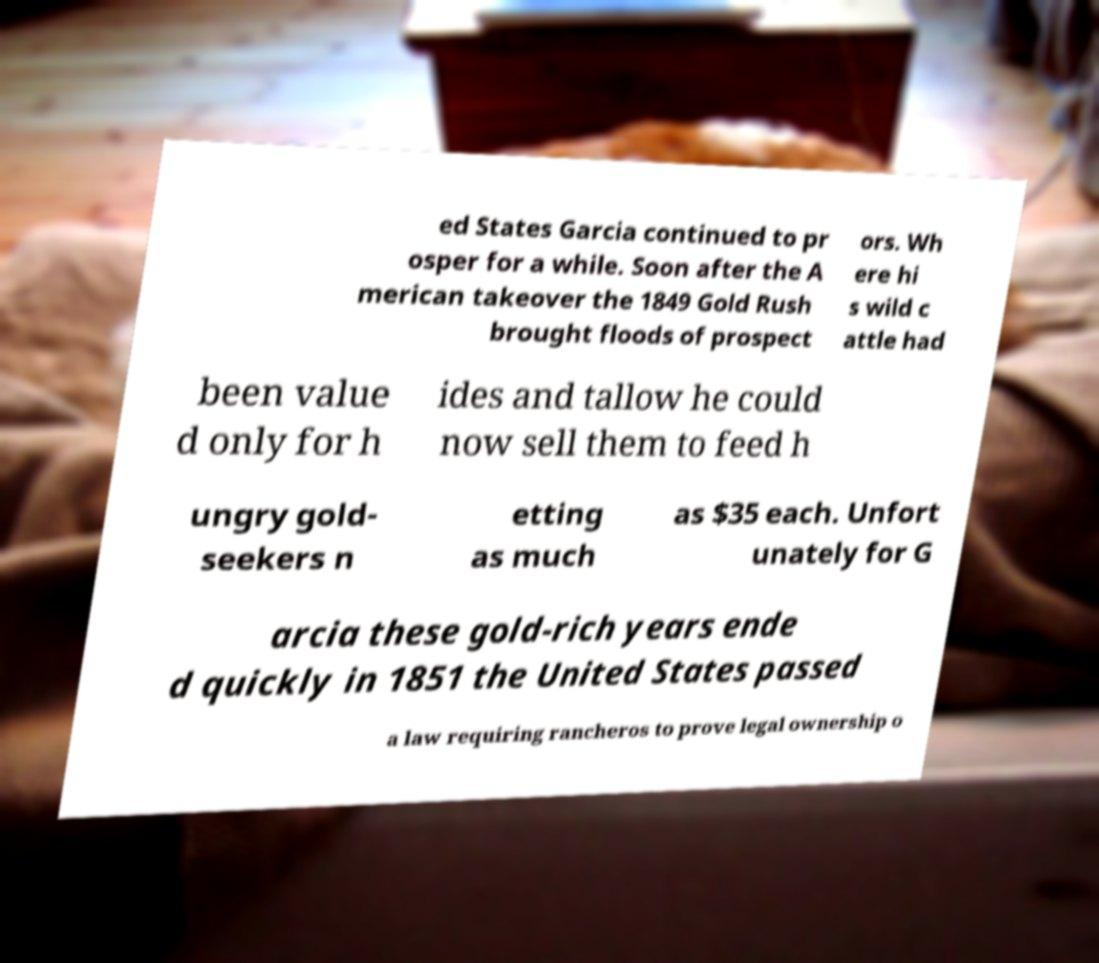What messages or text are displayed in this image? I need them in a readable, typed format. ed States Garcia continued to pr osper for a while. Soon after the A merican takeover the 1849 Gold Rush brought floods of prospect ors. Wh ere hi s wild c attle had been value d only for h ides and tallow he could now sell them to feed h ungry gold- seekers n etting as much as $35 each. Unfort unately for G arcia these gold-rich years ende d quickly in 1851 the United States passed a law requiring rancheros to prove legal ownership o 